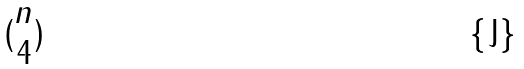<formula> <loc_0><loc_0><loc_500><loc_500>( \begin{matrix} n \\ 4 \end{matrix} )</formula> 